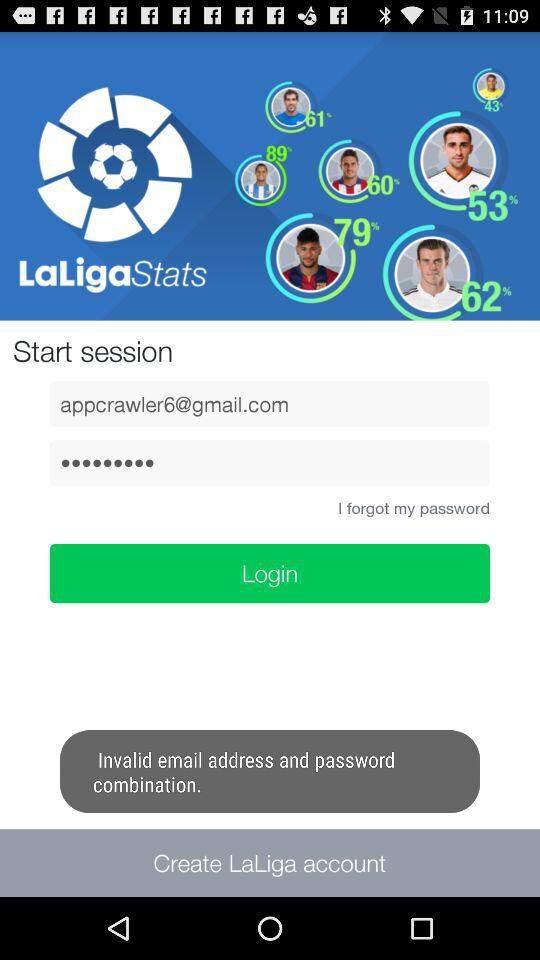What is the email address? The email address is "appcrawler6@gmail.com". 